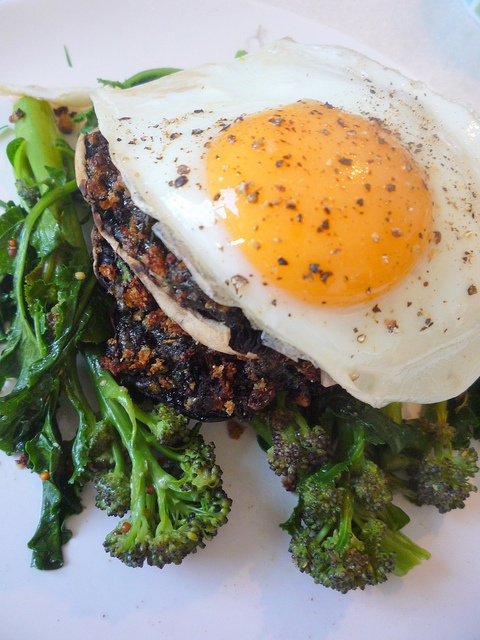Describe the objects in this image and their specific colors. I can see broccoli in lavender, black, darkgreen, and green tones and broccoli in lavender, black, darkgreen, and gray tones in this image. 